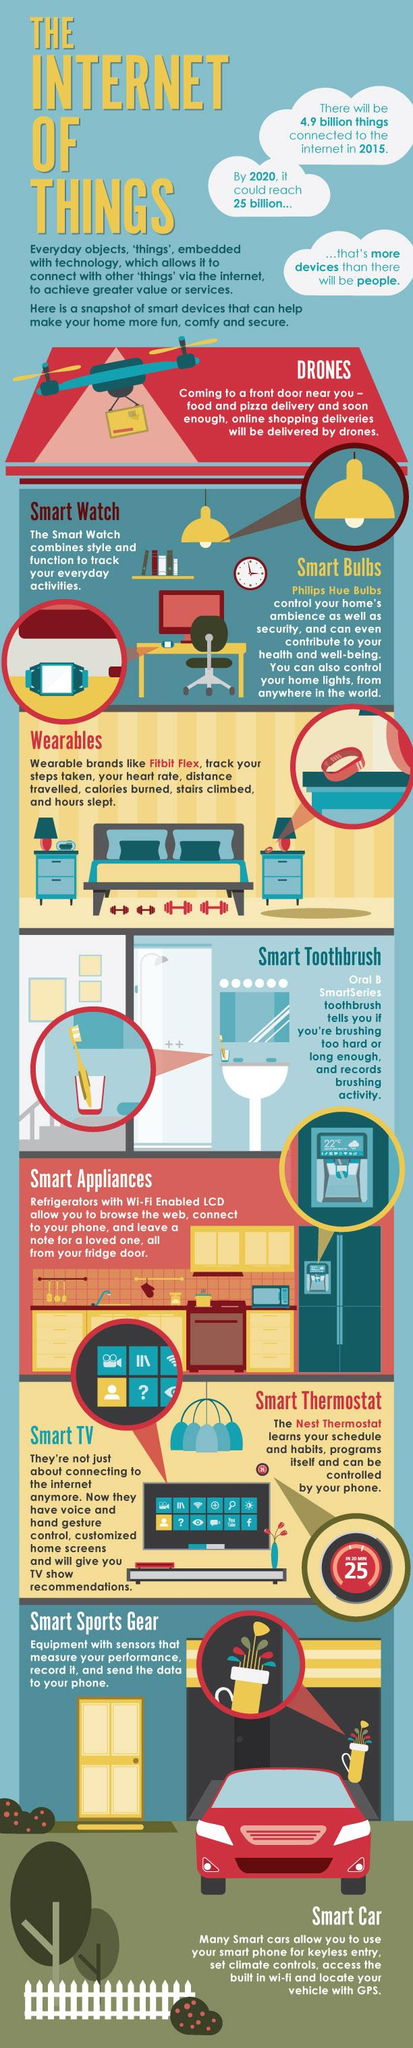Indicate a few pertinent items in this graphic. The color of the car is red. The color of the toothbrush is known as toothbrush-orange, which is a combination of orange and yellow, and it can also have a hint of red. 